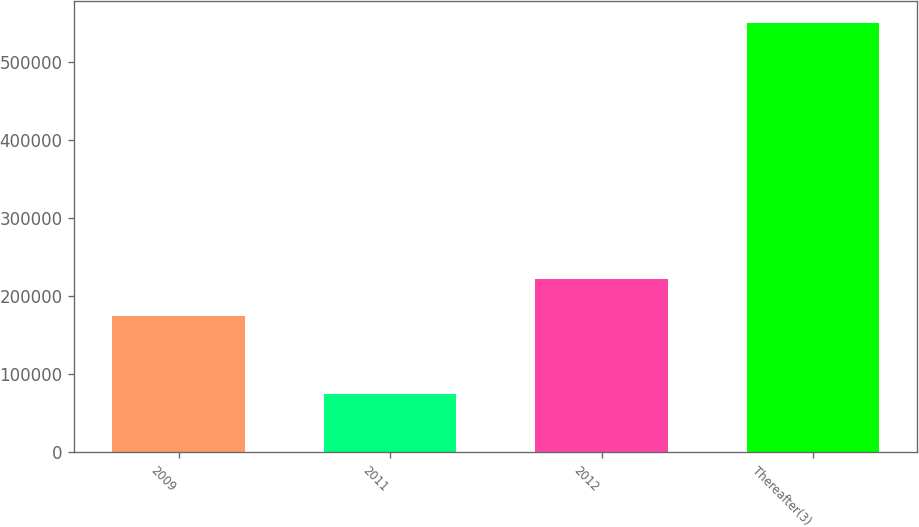Convert chart to OTSL. <chart><loc_0><loc_0><loc_500><loc_500><bar_chart><fcel>2009<fcel>2011<fcel>2012<fcel>Thereafter(3)<nl><fcel>175000<fcel>75000<fcel>222500<fcel>550000<nl></chart> 